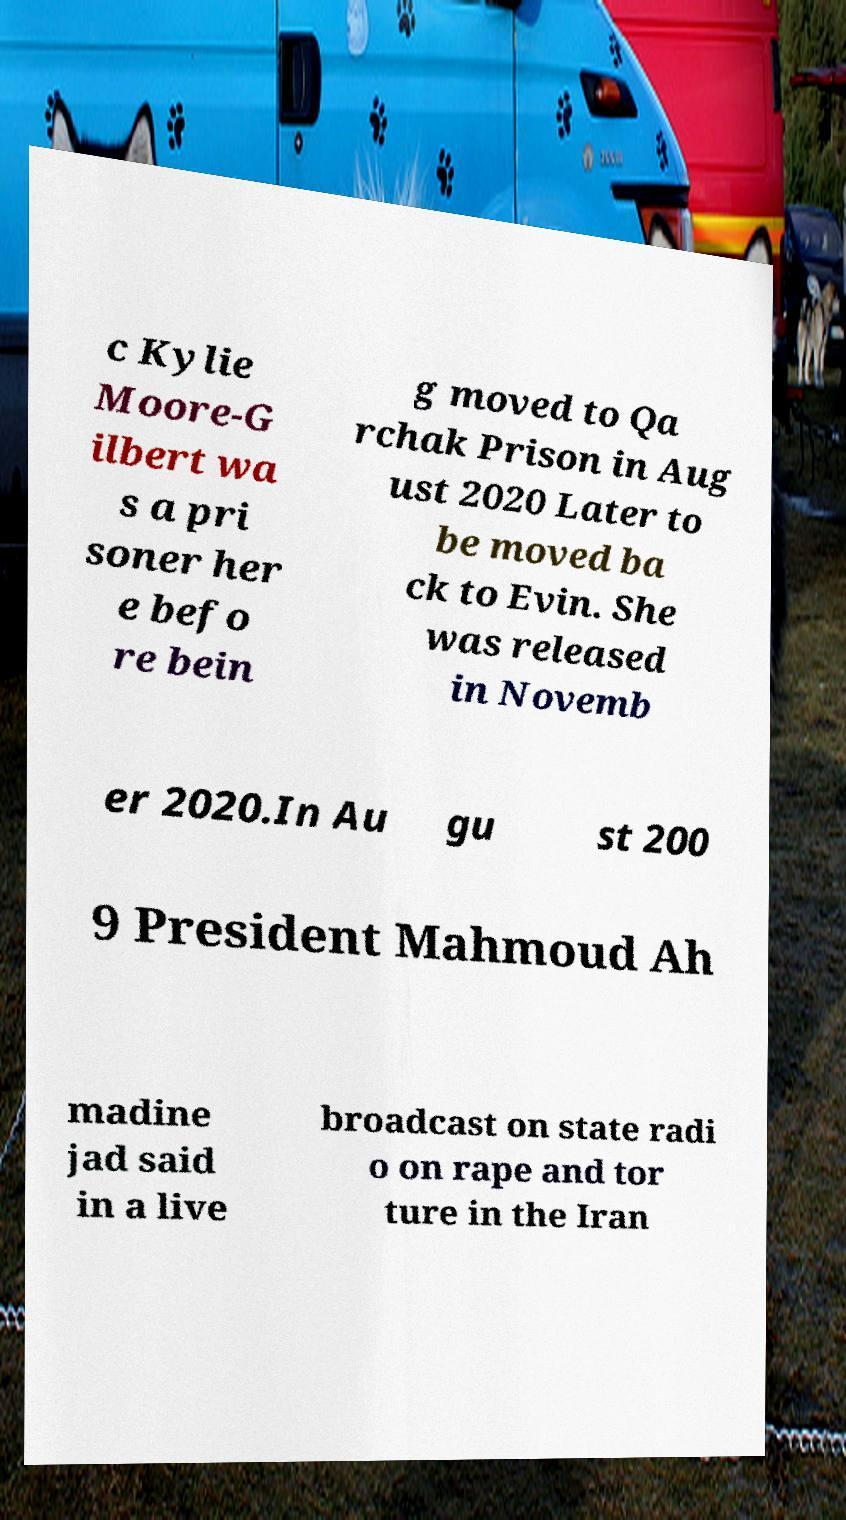Could you assist in decoding the text presented in this image and type it out clearly? c Kylie Moore-G ilbert wa s a pri soner her e befo re bein g moved to Qa rchak Prison in Aug ust 2020 Later to be moved ba ck to Evin. She was released in Novemb er 2020.In Au gu st 200 9 President Mahmoud Ah madine jad said in a live broadcast on state radi o on rape and tor ture in the Iran 